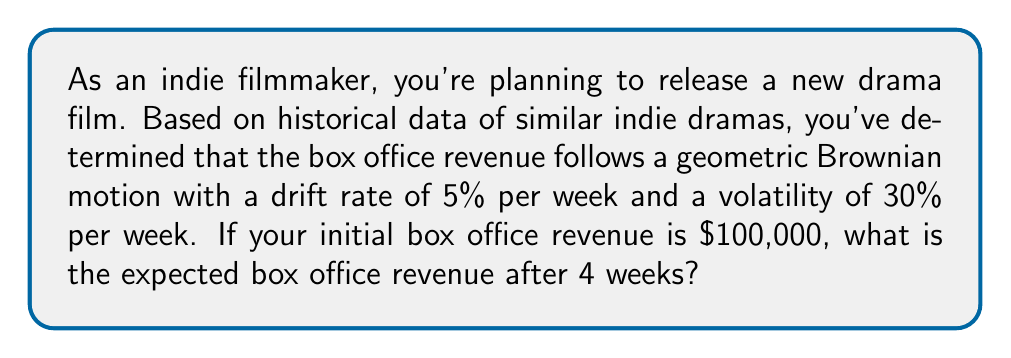Can you solve this math problem? Let's approach this step-by-step:

1) The geometric Brownian motion model for asset prices is given by the equation:

   $$S_t = S_0 \exp\left(\left(\mu - \frac{\sigma^2}{2}\right)t + \sigma W_t\right)$$

   Where:
   $S_t$ is the asset price at time $t$
   $S_0$ is the initial asset price
   $\mu$ is the drift rate
   $\sigma$ is the volatility
   $W_t$ is a Wiener process

2) For the expected value, we can use the simpler formula:

   $$E[S_t] = S_0 e^{\mu t}$$

3) In this case:
   $S_0 = 100,000$
   $\mu = 5\% = 0.05$ per week
   $t = 4$ weeks

4) Plugging these values into the formula:

   $$E[S_4] = 100,000 \cdot e^{0.05 \cdot 4}$$

5) Calculate:
   $$E[S_4] = 100,000 \cdot e^{0.2}$$
   $$E[S_4] = 100,000 \cdot 1.2214$$
   $$E[S_4] = 122,140$$

Therefore, the expected box office revenue after 4 weeks is $122,140.
Answer: $122,140 